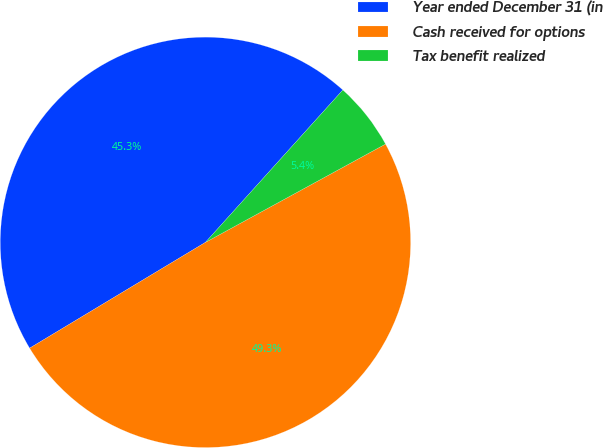Convert chart. <chart><loc_0><loc_0><loc_500><loc_500><pie_chart><fcel>Year ended December 31 (in<fcel>Cash received for options<fcel>Tax benefit realized<nl><fcel>45.3%<fcel>49.33%<fcel>5.37%<nl></chart> 